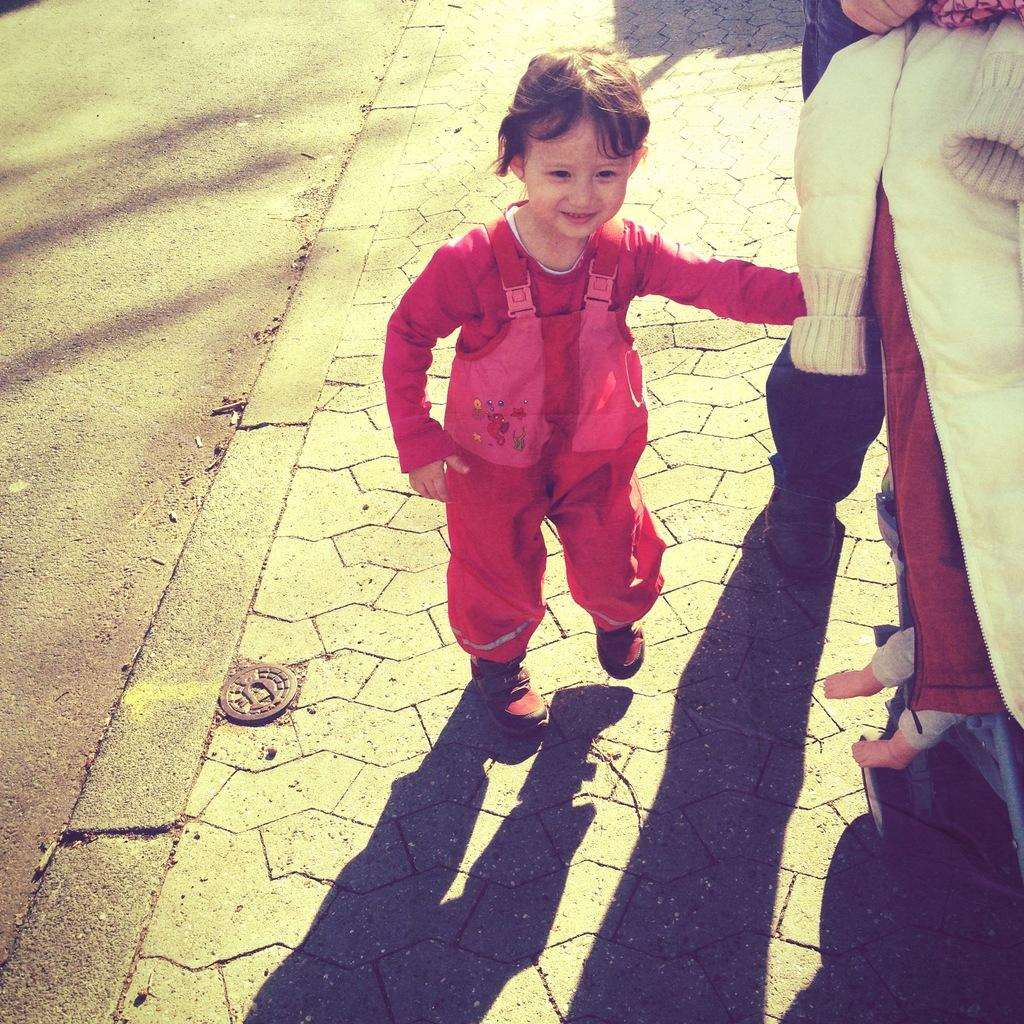Who is the main subject in the image? There is a girl in the image. What is the girl doing in the image? The girl is walking on the land. What is the girl wearing in the image? The girl is wearing a pink dress. Can you describe the person on the right side of the image? Unfortunately, the provided facts do not mention any details about the person on the right side of the image. What type of food is the girl eating while walking in the image? There is no food present in the image, and the girl is not eating anything. 